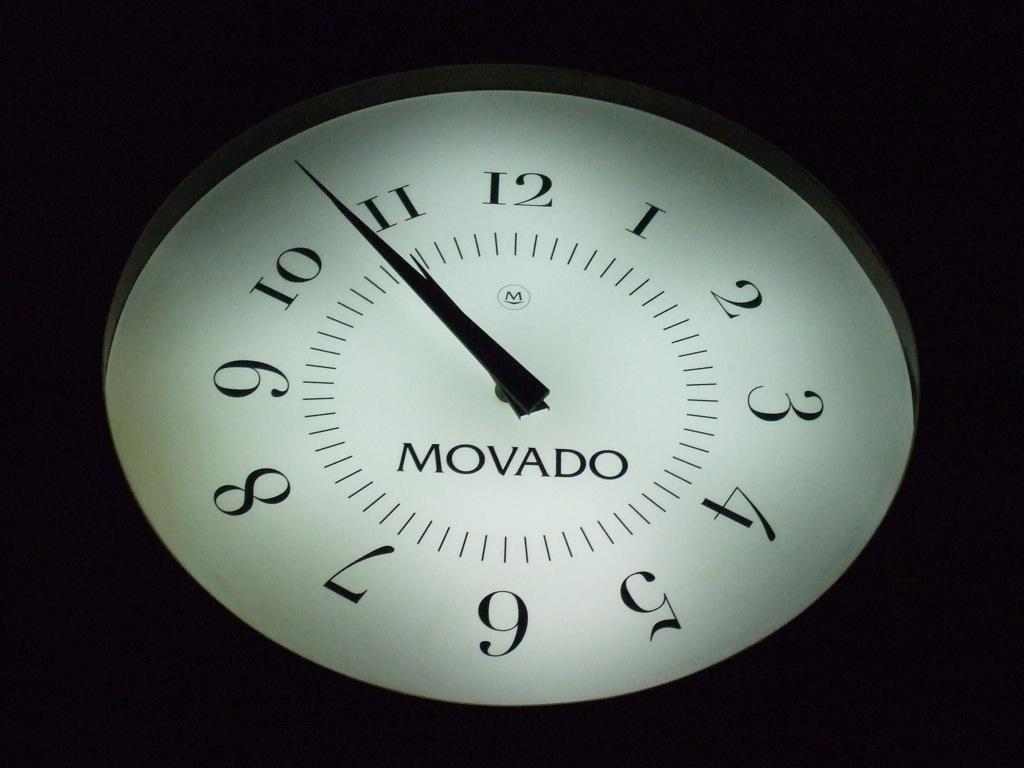<image>
Render a clear and concise summary of the photo. A Movado clock face glows with light, showing the current time. 